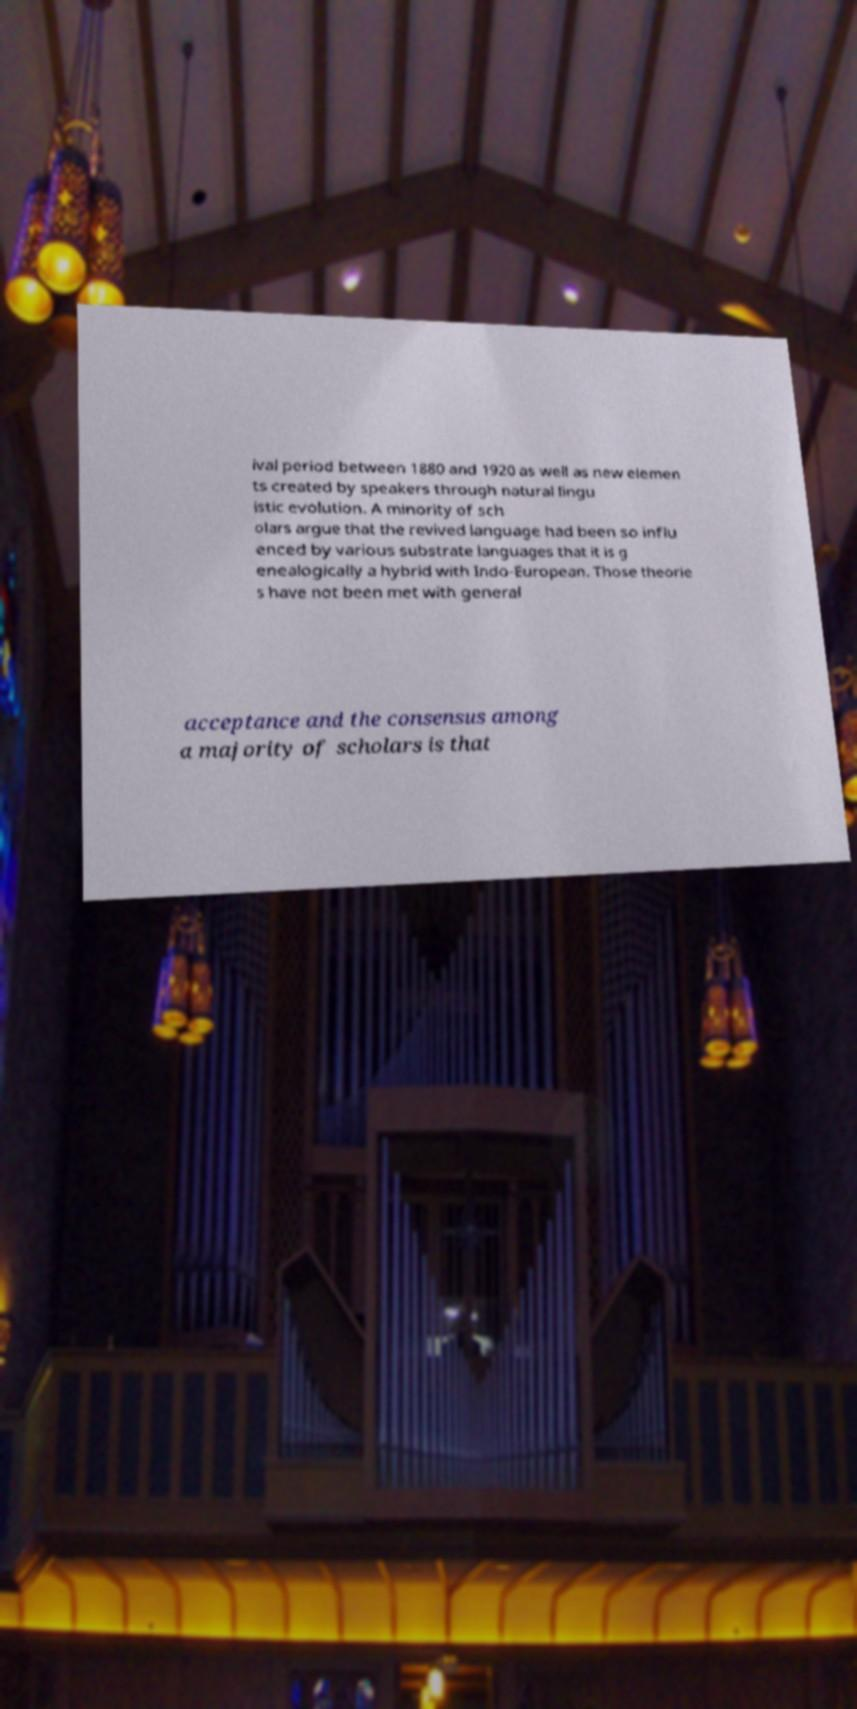Could you assist in decoding the text presented in this image and type it out clearly? ival period between 1880 and 1920 as well as new elemen ts created by speakers through natural lingu istic evolution. A minority of sch olars argue that the revived language had been so influ enced by various substrate languages that it is g enealogically a hybrid with Indo-European. Those theorie s have not been met with general acceptance and the consensus among a majority of scholars is that 